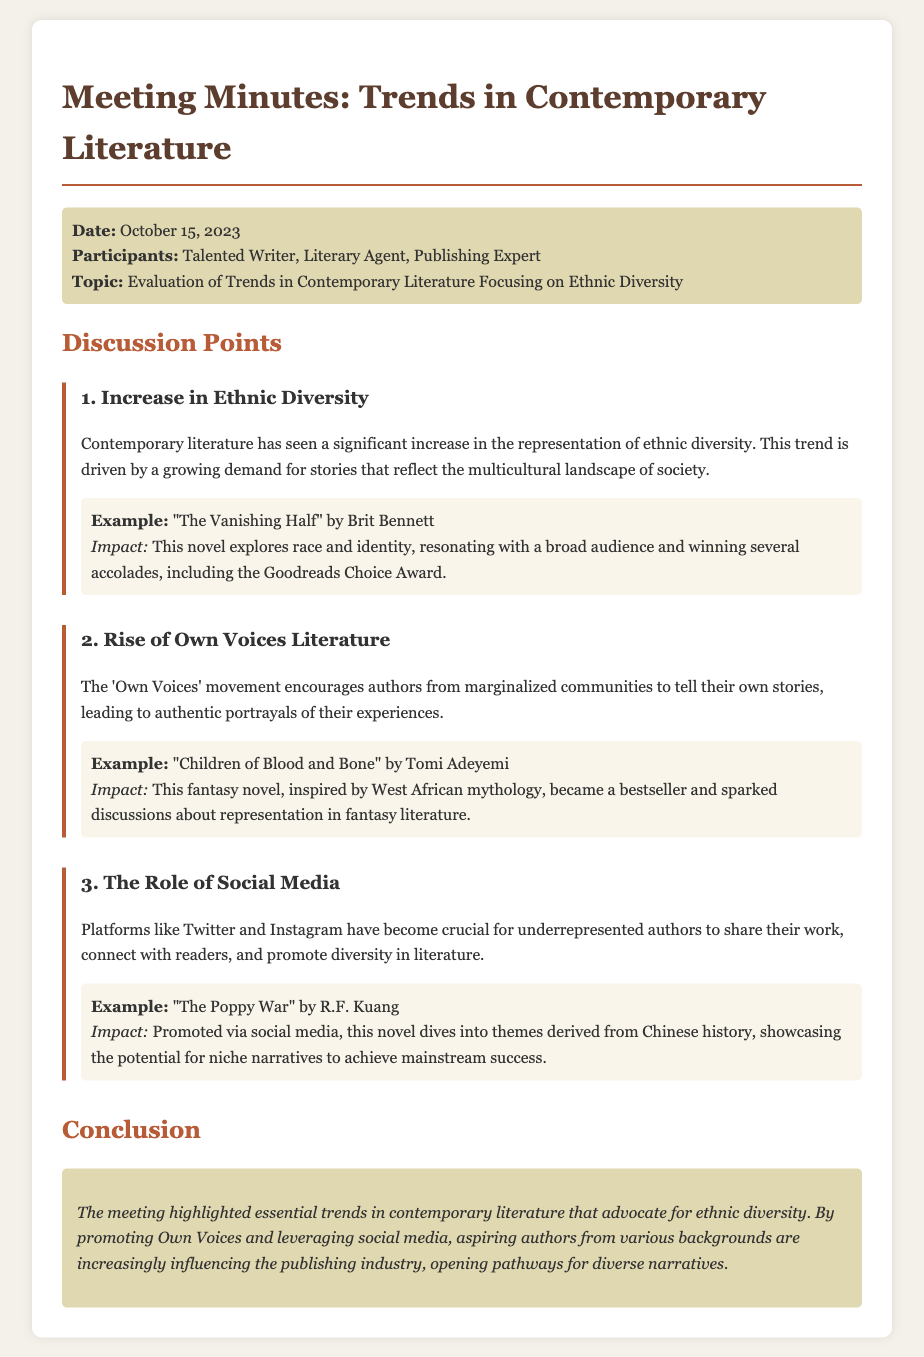What is the date of the meeting? The meeting took place on October 15, 2023, as stated in the document.
Answer: October 15, 2023 Who is a participant from the literary field? The document lists a Literary Agent as one of the participants in the meeting.
Answer: Literary Agent What is the title of the example novel by Brit Bennett? The document mentions "The Vanishing Half" as an example of a novel discussing race and identity.
Answer: The Vanishing Half What trend encourages authors from marginalized communities? The 'Own Voices' movement is highlighted as encouraging these authors to tell their own stories.
Answer: Own Voices Which novel explores themes derived from Chinese history? "The Poppy War" is noted as diving into themes from Chinese history in the document.
Answer: The Poppy War What accolade did "The Vanishing Half" win? The document states that the novel won the Goodreads Choice Award.
Answer: Goodreads Choice Award How does social media play a role in contemporary literature according to the document? The document mentions that social media platforms help underrepresented authors share their work and promote diversity.
Answer: Share work and promote diversity What is the impact of "Children of Blood and Bone"? The document indicates that this novel sparked discussions about representation in fantasy literature.
Answer: Sparked discussions about representation What is a primary conclusion of the meeting? The document concludes that aspiring authors from various backgrounds are influencing the publishing industry.
Answer: Aspiring authors are influencing the publishing industry 